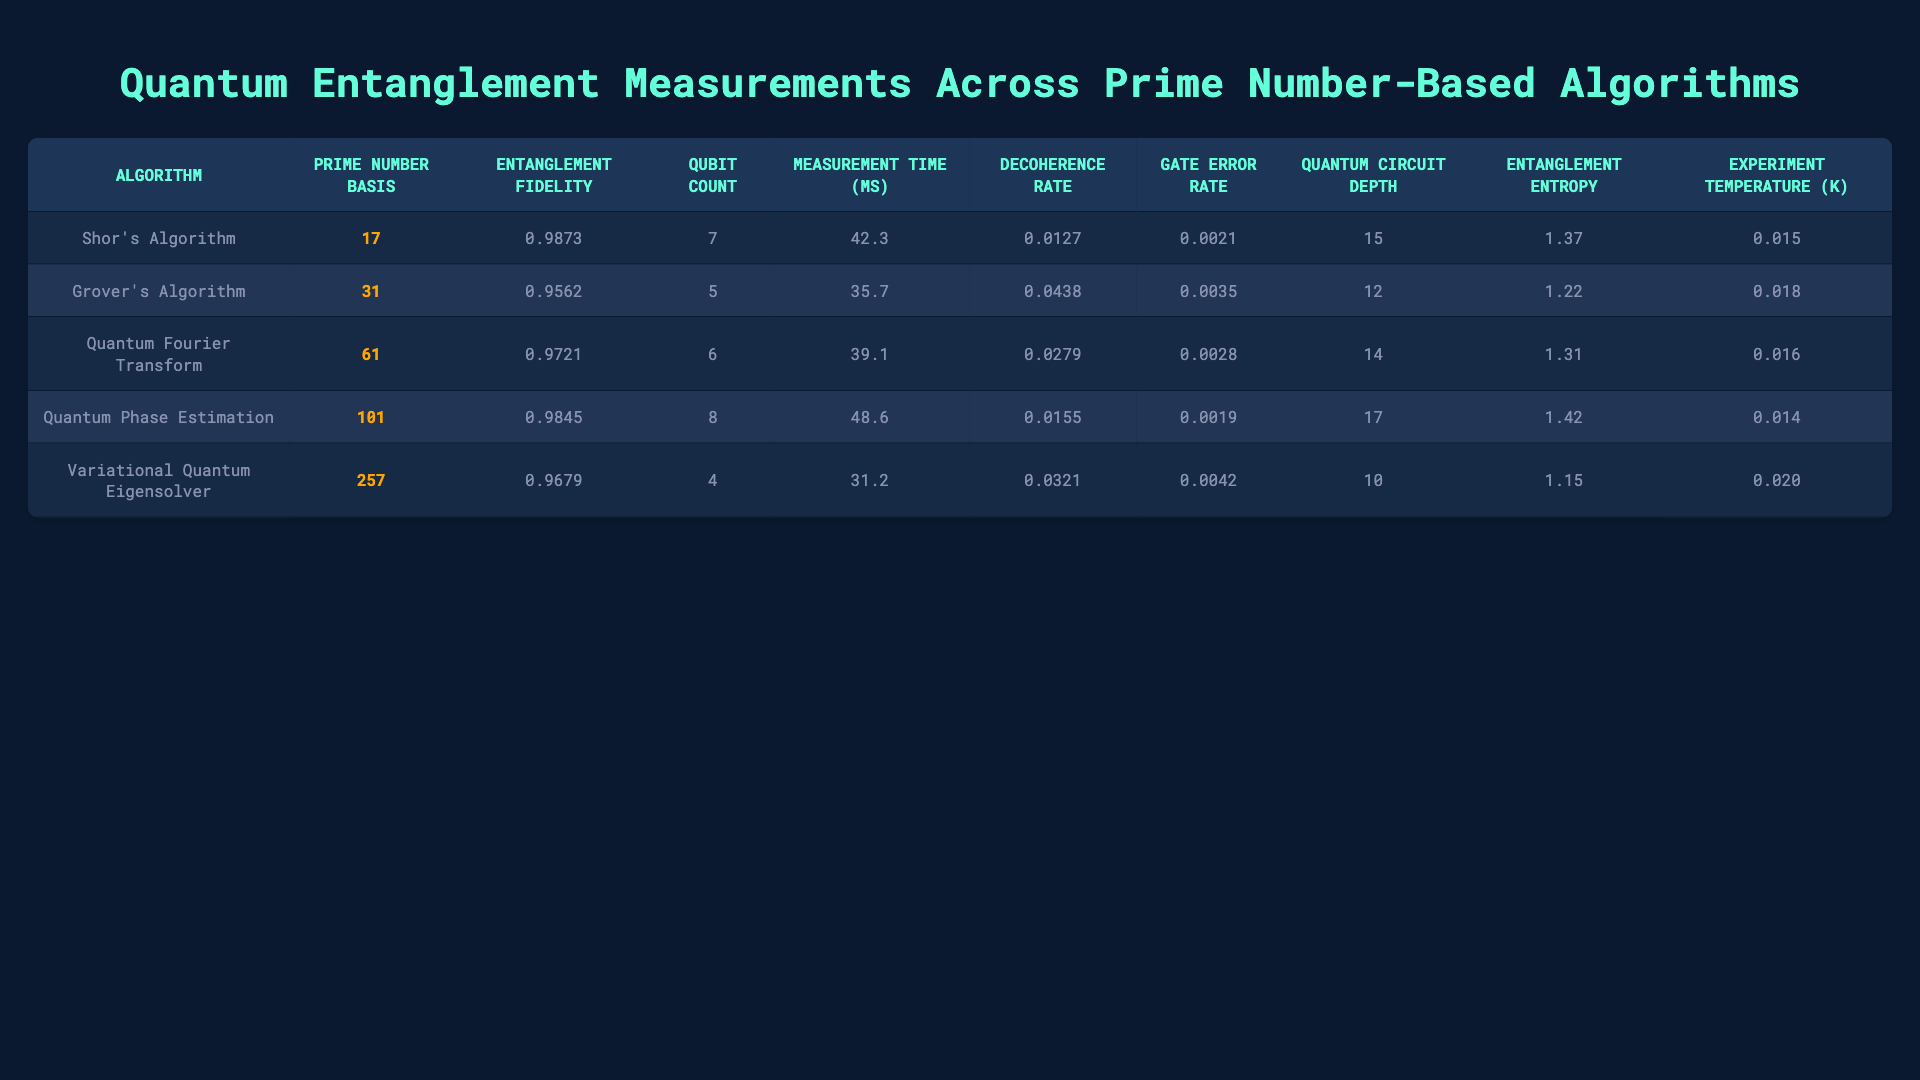What is the entanglement fidelity for Shor's Algorithm? According to the table, the entanglement fidelity for Shor's Algorithm is listed directly under that algorithm. The value is 0.9873.
Answer: 0.9873 Which algorithm has the highest gate error rate? By examining the gate error rates for each algorithm, it can be seen that Variational Quantum Eigensolver has the highest value at 0.0042.
Answer: Variational Quantum Eigensolver What is the difference in measurement time between Grover's Algorithm and the Quantum Phase Estimation? Looking at the measurement times for both algorithms, Grover's Algorithm has a time of 35.7 ms while Quantum Phase Estimation has a time of 48.6 ms. The difference is calculated as 48.6 - 35.7 = 12.9 ms.
Answer: 12.9 ms How many qubits are used in the Quantum Fourier Transform? The table shows that the Quantum Fourier Transform utilizes a total of 6 qubits.
Answer: 6 What is the average entanglement entropy across all algorithms? To find the average entanglement entropy, sum the values (1.37 + 1.22 + 1.31 + 1.42 + 1.15) = 6.47. Then divide by 5 (the number of algorithms) to get the average: 6.47 / 5 = 1.294.
Answer: 1.294 Is the decoherence rate for the Quantum Phase Estimation higher than that for Shor's Algorithm? The table shows that the decoherence rate for Quantum Phase Estimation is 0.0155, while for Shor's Algorithm it is 0.0127. Since 0.0155 is greater than 0.0127, the statement is true.
Answer: Yes Which algorithm has the lowest entanglement fidelity, and what is its value? By checking the entanglement fidelity values for all algorithms, Grover's Algorithm has the lowest value at 0.9562.
Answer: Grover's Algorithm, 0.9562 If we sum the qubit counts used in all algorithms, what is the total? Summing the qubit counts gives (7 + 5 + 6 + 8 + 4) = 30.
Answer: 30 Is the measurement time for the Variational Quantum Eigensolver less than 40 ms? The measurement time for the Variational Quantum Eigensolver is 31.2 ms, which is less than 40 ms, making the statement true.
Answer: Yes What can be said about the relationship between the gate error rate and the qubit count for this set of algorithms? By examining the table, a general trend can be observed that algorithms with higher qubit counts do not necessarily have lower gate error rates; Variational Quantum Eigensolver has the least qubits (4) but the highest gate error rate (0.0042). This suggests that more qubits do not lead to better gate error rates.
Answer: More qubits do not guarantee lower gate error rates 